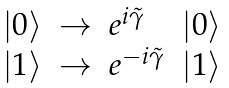<formula> <loc_0><loc_0><loc_500><loc_500>\begin{array} { l c l l } | 0 \rangle & \rightarrow & e ^ { i \tilde { \gamma } } & | 0 \rangle \\ | 1 \rangle & \rightarrow & e ^ { - i \tilde { \gamma } } & | 1 \rangle \end{array}</formula> 